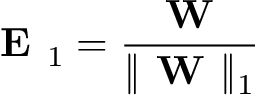Convert formula to latex. <formula><loc_0><loc_0><loc_500><loc_500>E _ { 1 } = \frac { W } { \| W \| _ { 1 } }</formula> 